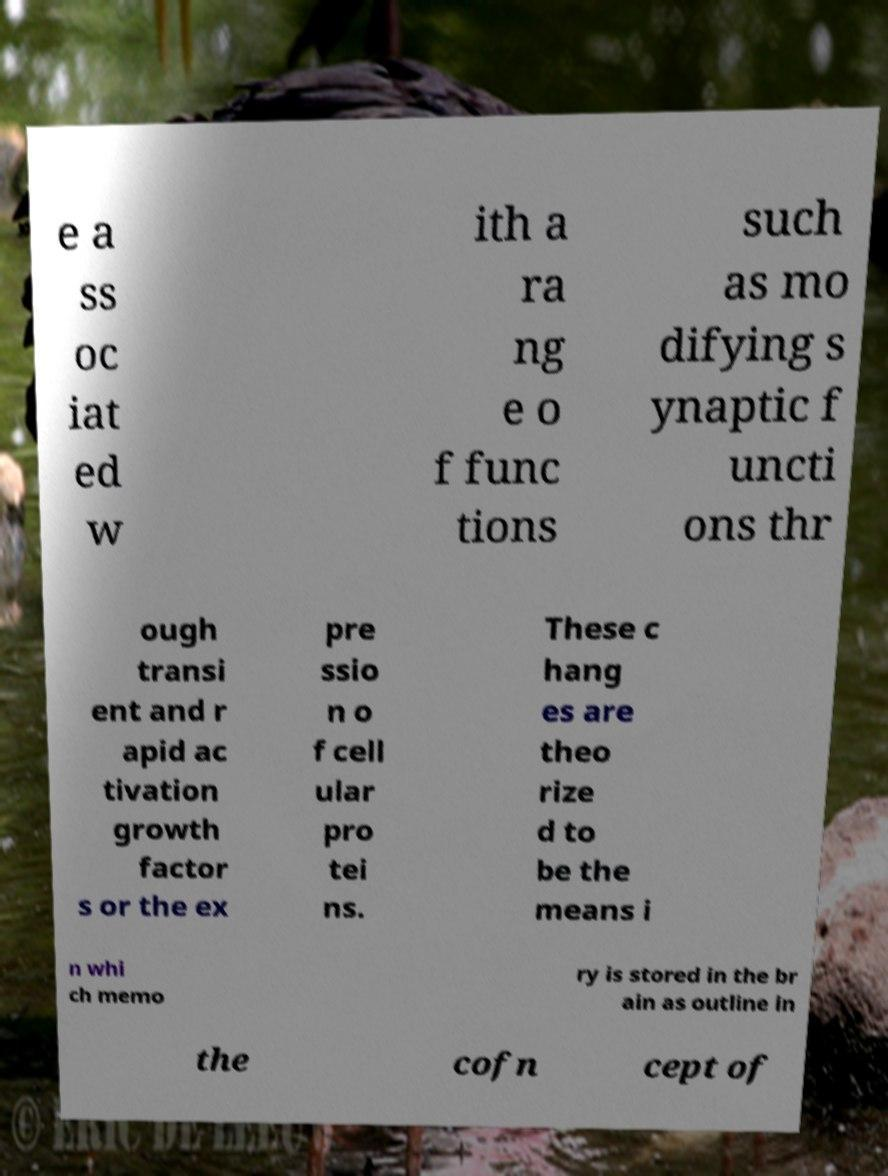What messages or text are displayed in this image? I need them in a readable, typed format. e a ss oc iat ed w ith a ra ng e o f func tions such as mo difying s ynaptic f uncti ons thr ough transi ent and r apid ac tivation growth factor s or the ex pre ssio n o f cell ular pro tei ns. These c hang es are theo rize d to be the means i n whi ch memo ry is stored in the br ain as outline in the cofn cept of 